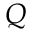Convert formula to latex. <formula><loc_0><loc_0><loc_500><loc_500>Q</formula> 